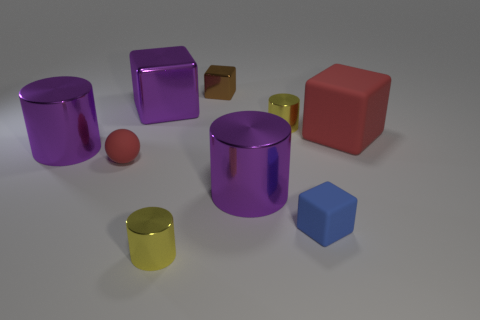Add 1 big gray metallic objects. How many objects exist? 10 Subtract all cylinders. How many objects are left? 5 Subtract 1 red spheres. How many objects are left? 8 Subtract all small red balls. Subtract all brown things. How many objects are left? 7 Add 5 red things. How many red things are left? 7 Add 1 cylinders. How many cylinders exist? 5 